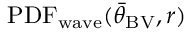Convert formula to latex. <formula><loc_0><loc_0><loc_500><loc_500>P D F _ { w a v e } ( { \bar { \theta } } _ { B V } , r )</formula> 